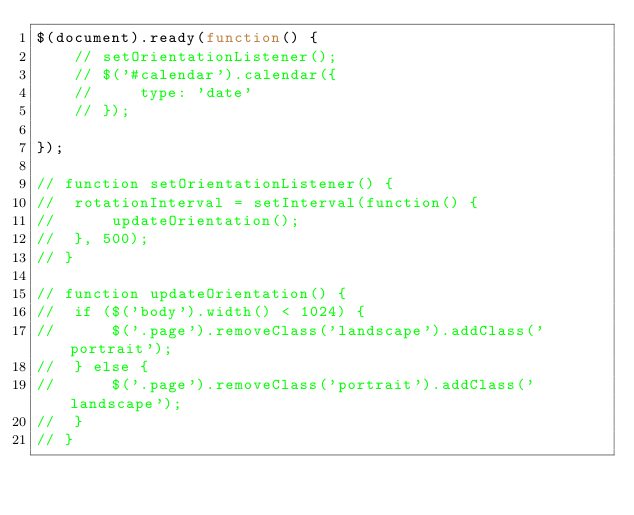Convert code to text. <code><loc_0><loc_0><loc_500><loc_500><_JavaScript_>$(document).ready(function() {
    // setOrientationListener(); 
    // $('#calendar').calendar({
    //     type: 'date'
    // });

});

// function setOrientationListener() {
//  rotationInterval = setInterval(function() {
//      updateOrientation();
//  }, 500);
// }

// function updateOrientation() {
//  if ($('body').width() < 1024) {
//      $('.page').removeClass('landscape').addClass('portrait');
//  } else {
//      $('.page').removeClass('portrait').addClass('landscape');
//  }
// }</code> 